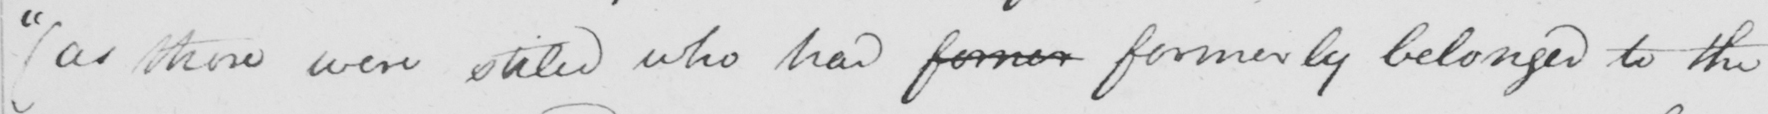What text is written in this handwritten line? "  ( as those were stiled who had former formerly belonged to the 